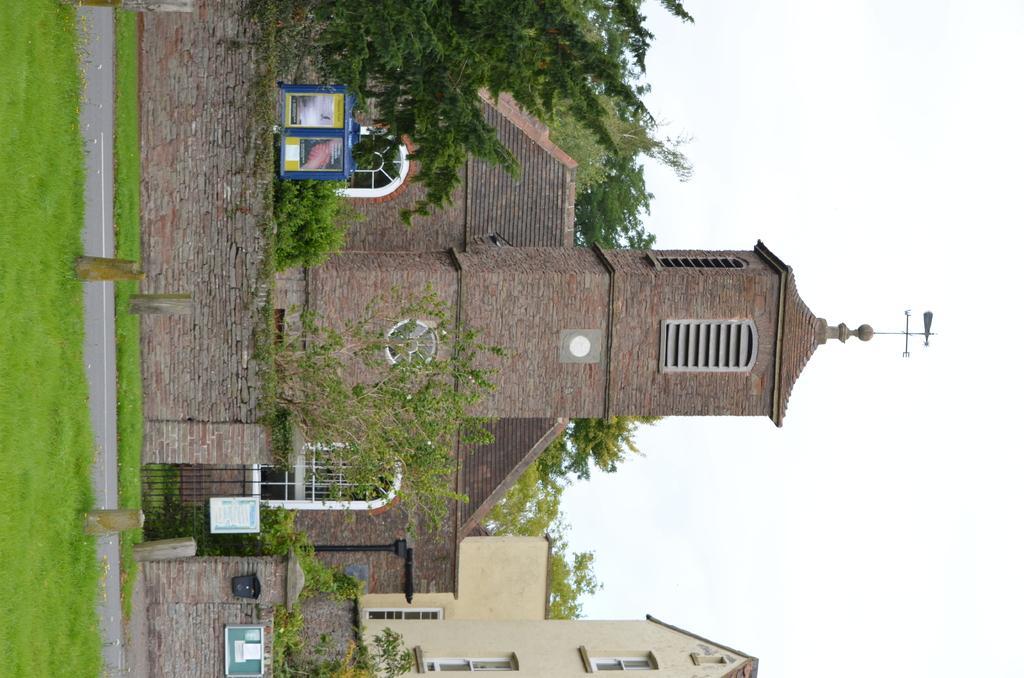How would you summarize this image in a sentence or two? In this image, we can see few buildings, trees and plants. Here we can see few boards, gate, wall. Left side of the image, there is a grass, road, some poles. Right side of the image, we can see the direction pole and sky. 